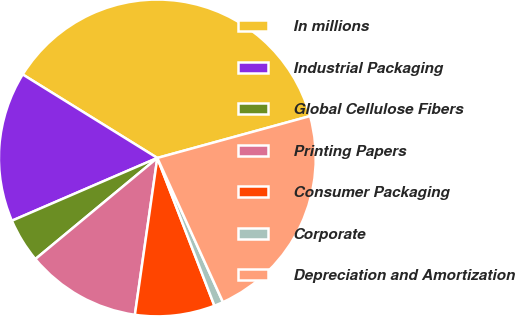Convert chart to OTSL. <chart><loc_0><loc_0><loc_500><loc_500><pie_chart><fcel>In millions<fcel>Industrial Packaging<fcel>Global Cellulose Fibers<fcel>Printing Papers<fcel>Consumer Packaging<fcel>Corporate<fcel>Depreciation and Amortization<nl><fcel>36.9%<fcel>15.32%<fcel>4.53%<fcel>11.72%<fcel>8.13%<fcel>0.93%<fcel>22.46%<nl></chart> 